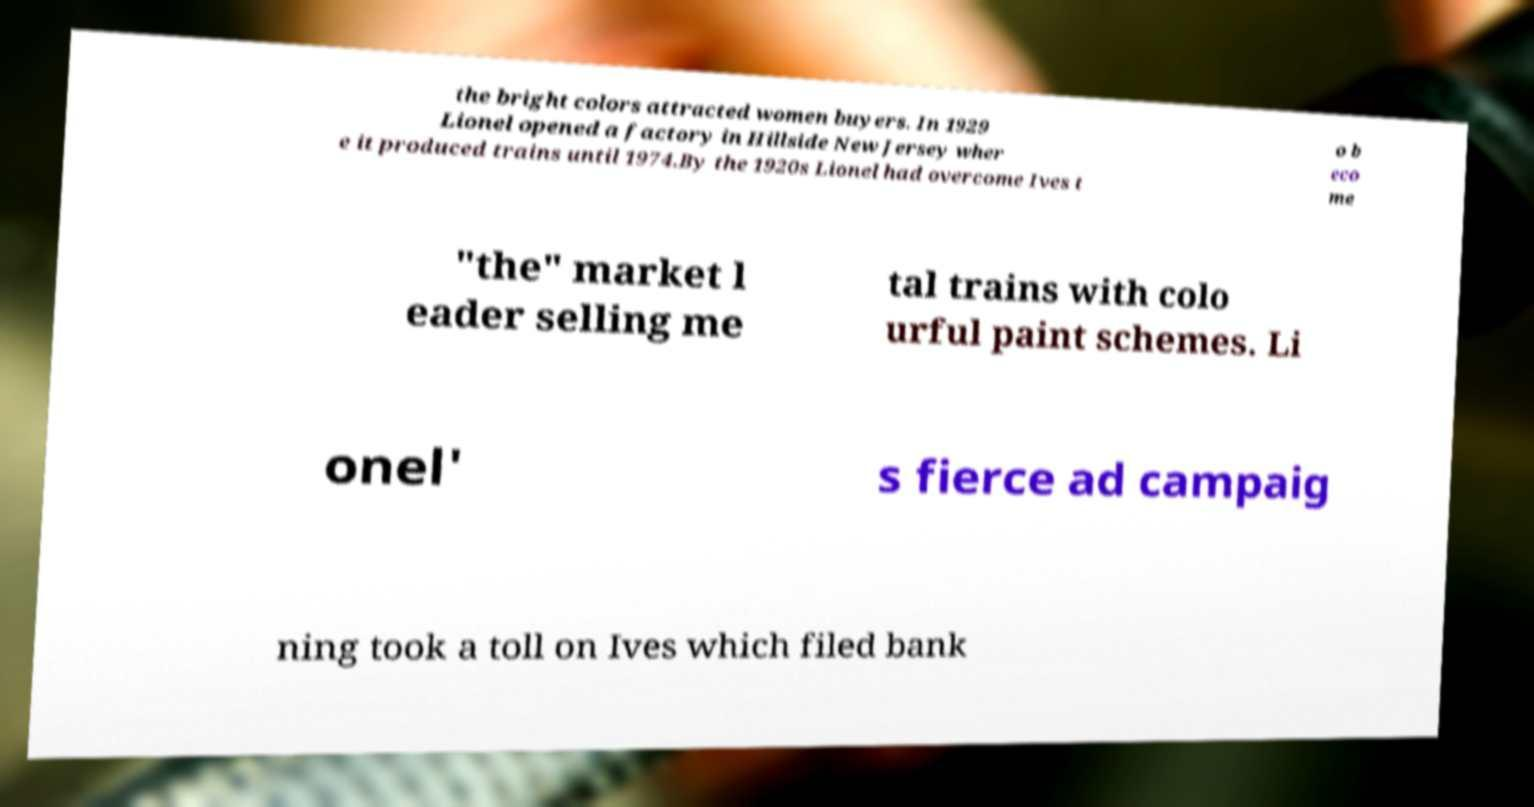Can you accurately transcribe the text from the provided image for me? the bright colors attracted women buyers. In 1929 Lionel opened a factory in Hillside New Jersey wher e it produced trains until 1974.By the 1920s Lionel had overcome Ives t o b eco me "the" market l eader selling me tal trains with colo urful paint schemes. Li onel' s fierce ad campaig ning took a toll on Ives which filed bank 